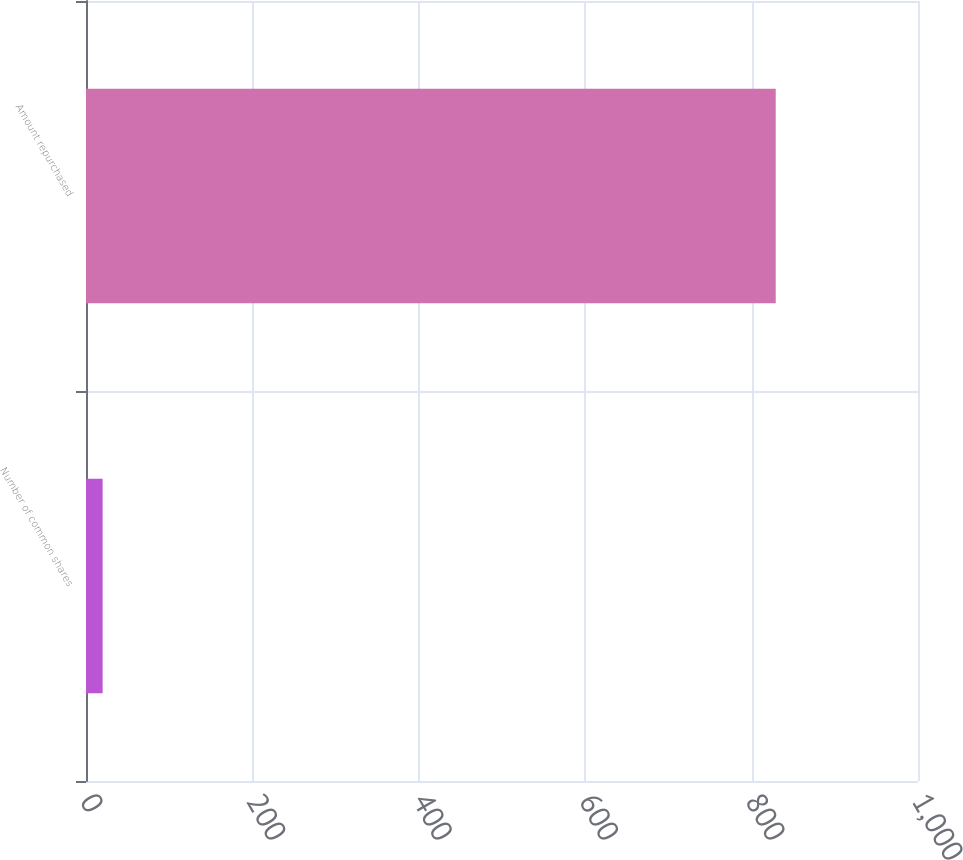Convert chart. <chart><loc_0><loc_0><loc_500><loc_500><bar_chart><fcel>Number of common shares<fcel>Amount repurchased<nl><fcel>20<fcel>829<nl></chart> 